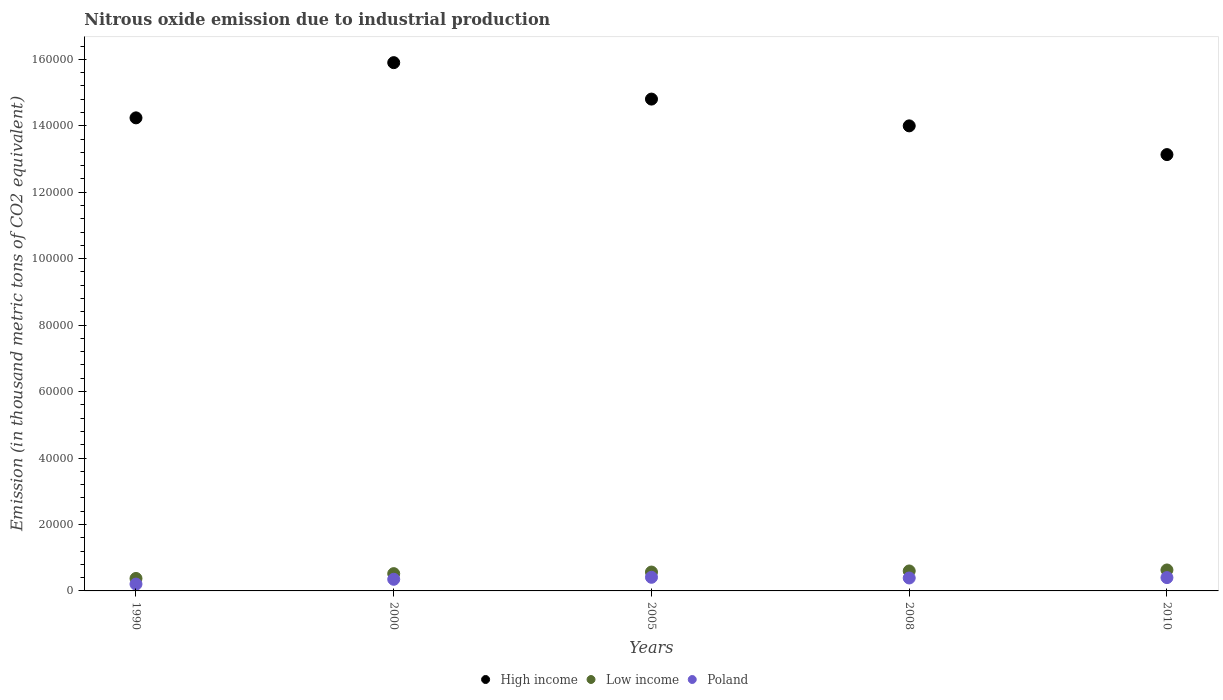How many different coloured dotlines are there?
Your answer should be compact. 3. Is the number of dotlines equal to the number of legend labels?
Your response must be concise. Yes. What is the amount of nitrous oxide emitted in High income in 2000?
Provide a succinct answer. 1.59e+05. Across all years, what is the maximum amount of nitrous oxide emitted in Low income?
Provide a short and direct response. 6305.5. Across all years, what is the minimum amount of nitrous oxide emitted in Poland?
Your answer should be very brief. 2055.6. In which year was the amount of nitrous oxide emitted in High income minimum?
Keep it short and to the point. 2010. What is the total amount of nitrous oxide emitted in High income in the graph?
Ensure brevity in your answer.  7.21e+05. What is the difference between the amount of nitrous oxide emitted in Poland in 2005 and that in 2010?
Your answer should be compact. 92.5. What is the difference between the amount of nitrous oxide emitted in Poland in 2010 and the amount of nitrous oxide emitted in High income in 2008?
Give a very brief answer. -1.36e+05. What is the average amount of nitrous oxide emitted in Low income per year?
Offer a terse response. 5389.32. In the year 2008, what is the difference between the amount of nitrous oxide emitted in Low income and amount of nitrous oxide emitted in High income?
Keep it short and to the point. -1.34e+05. In how many years, is the amount of nitrous oxide emitted in Low income greater than 120000 thousand metric tons?
Keep it short and to the point. 0. What is the ratio of the amount of nitrous oxide emitted in High income in 2008 to that in 2010?
Give a very brief answer. 1.07. Is the amount of nitrous oxide emitted in Low income in 1990 less than that in 2000?
Ensure brevity in your answer.  Yes. Is the difference between the amount of nitrous oxide emitted in Low income in 2000 and 2010 greater than the difference between the amount of nitrous oxide emitted in High income in 2000 and 2010?
Make the answer very short. No. What is the difference between the highest and the second highest amount of nitrous oxide emitted in Low income?
Give a very brief answer. 298. What is the difference between the highest and the lowest amount of nitrous oxide emitted in Low income?
Give a very brief answer. 2554.2. In how many years, is the amount of nitrous oxide emitted in Poland greater than the average amount of nitrous oxide emitted in Poland taken over all years?
Offer a terse response. 3. Is it the case that in every year, the sum of the amount of nitrous oxide emitted in High income and amount of nitrous oxide emitted in Low income  is greater than the amount of nitrous oxide emitted in Poland?
Offer a terse response. Yes. What is the difference between two consecutive major ticks on the Y-axis?
Ensure brevity in your answer.  2.00e+04. Are the values on the major ticks of Y-axis written in scientific E-notation?
Provide a succinct answer. No. Does the graph contain any zero values?
Your response must be concise. No. Where does the legend appear in the graph?
Offer a terse response. Bottom center. What is the title of the graph?
Provide a short and direct response. Nitrous oxide emission due to industrial production. Does "Belgium" appear as one of the legend labels in the graph?
Keep it short and to the point. No. What is the label or title of the Y-axis?
Give a very brief answer. Emission (in thousand metric tons of CO2 equivalent). What is the Emission (in thousand metric tons of CO2 equivalent) of High income in 1990?
Give a very brief answer. 1.42e+05. What is the Emission (in thousand metric tons of CO2 equivalent) in Low income in 1990?
Offer a very short reply. 3751.3. What is the Emission (in thousand metric tons of CO2 equivalent) of Poland in 1990?
Offer a very short reply. 2055.6. What is the Emission (in thousand metric tons of CO2 equivalent) of High income in 2000?
Give a very brief answer. 1.59e+05. What is the Emission (in thousand metric tons of CO2 equivalent) in Low income in 2000?
Make the answer very short. 5201.5. What is the Emission (in thousand metric tons of CO2 equivalent) of Poland in 2000?
Offer a very short reply. 3499.7. What is the Emission (in thousand metric tons of CO2 equivalent) in High income in 2005?
Ensure brevity in your answer.  1.48e+05. What is the Emission (in thousand metric tons of CO2 equivalent) of Low income in 2005?
Keep it short and to the point. 5680.8. What is the Emission (in thousand metric tons of CO2 equivalent) of Poland in 2005?
Offer a terse response. 4101.5. What is the Emission (in thousand metric tons of CO2 equivalent) in High income in 2008?
Your answer should be compact. 1.40e+05. What is the Emission (in thousand metric tons of CO2 equivalent) of Low income in 2008?
Your answer should be compact. 6007.5. What is the Emission (in thousand metric tons of CO2 equivalent) in Poland in 2008?
Provide a succinct answer. 3892.6. What is the Emission (in thousand metric tons of CO2 equivalent) of High income in 2010?
Provide a succinct answer. 1.31e+05. What is the Emission (in thousand metric tons of CO2 equivalent) in Low income in 2010?
Your answer should be very brief. 6305.5. What is the Emission (in thousand metric tons of CO2 equivalent) of Poland in 2010?
Make the answer very short. 4009. Across all years, what is the maximum Emission (in thousand metric tons of CO2 equivalent) in High income?
Your answer should be compact. 1.59e+05. Across all years, what is the maximum Emission (in thousand metric tons of CO2 equivalent) in Low income?
Your answer should be very brief. 6305.5. Across all years, what is the maximum Emission (in thousand metric tons of CO2 equivalent) in Poland?
Provide a short and direct response. 4101.5. Across all years, what is the minimum Emission (in thousand metric tons of CO2 equivalent) in High income?
Give a very brief answer. 1.31e+05. Across all years, what is the minimum Emission (in thousand metric tons of CO2 equivalent) in Low income?
Your response must be concise. 3751.3. Across all years, what is the minimum Emission (in thousand metric tons of CO2 equivalent) of Poland?
Offer a terse response. 2055.6. What is the total Emission (in thousand metric tons of CO2 equivalent) in High income in the graph?
Give a very brief answer. 7.21e+05. What is the total Emission (in thousand metric tons of CO2 equivalent) of Low income in the graph?
Provide a short and direct response. 2.69e+04. What is the total Emission (in thousand metric tons of CO2 equivalent) in Poland in the graph?
Ensure brevity in your answer.  1.76e+04. What is the difference between the Emission (in thousand metric tons of CO2 equivalent) in High income in 1990 and that in 2000?
Offer a terse response. -1.66e+04. What is the difference between the Emission (in thousand metric tons of CO2 equivalent) in Low income in 1990 and that in 2000?
Your response must be concise. -1450.2. What is the difference between the Emission (in thousand metric tons of CO2 equivalent) of Poland in 1990 and that in 2000?
Offer a terse response. -1444.1. What is the difference between the Emission (in thousand metric tons of CO2 equivalent) in High income in 1990 and that in 2005?
Keep it short and to the point. -5648.4. What is the difference between the Emission (in thousand metric tons of CO2 equivalent) of Low income in 1990 and that in 2005?
Make the answer very short. -1929.5. What is the difference between the Emission (in thousand metric tons of CO2 equivalent) in Poland in 1990 and that in 2005?
Your response must be concise. -2045.9. What is the difference between the Emission (in thousand metric tons of CO2 equivalent) of High income in 1990 and that in 2008?
Your answer should be very brief. 2410.2. What is the difference between the Emission (in thousand metric tons of CO2 equivalent) of Low income in 1990 and that in 2008?
Offer a terse response. -2256.2. What is the difference between the Emission (in thousand metric tons of CO2 equivalent) in Poland in 1990 and that in 2008?
Give a very brief answer. -1837. What is the difference between the Emission (in thousand metric tons of CO2 equivalent) of High income in 1990 and that in 2010?
Offer a terse response. 1.11e+04. What is the difference between the Emission (in thousand metric tons of CO2 equivalent) in Low income in 1990 and that in 2010?
Your answer should be very brief. -2554.2. What is the difference between the Emission (in thousand metric tons of CO2 equivalent) in Poland in 1990 and that in 2010?
Ensure brevity in your answer.  -1953.4. What is the difference between the Emission (in thousand metric tons of CO2 equivalent) in High income in 2000 and that in 2005?
Offer a terse response. 1.10e+04. What is the difference between the Emission (in thousand metric tons of CO2 equivalent) of Low income in 2000 and that in 2005?
Your response must be concise. -479.3. What is the difference between the Emission (in thousand metric tons of CO2 equivalent) in Poland in 2000 and that in 2005?
Your answer should be very brief. -601.8. What is the difference between the Emission (in thousand metric tons of CO2 equivalent) in High income in 2000 and that in 2008?
Your response must be concise. 1.90e+04. What is the difference between the Emission (in thousand metric tons of CO2 equivalent) in Low income in 2000 and that in 2008?
Offer a terse response. -806. What is the difference between the Emission (in thousand metric tons of CO2 equivalent) in Poland in 2000 and that in 2008?
Keep it short and to the point. -392.9. What is the difference between the Emission (in thousand metric tons of CO2 equivalent) of High income in 2000 and that in 2010?
Your answer should be very brief. 2.77e+04. What is the difference between the Emission (in thousand metric tons of CO2 equivalent) of Low income in 2000 and that in 2010?
Provide a succinct answer. -1104. What is the difference between the Emission (in thousand metric tons of CO2 equivalent) in Poland in 2000 and that in 2010?
Offer a very short reply. -509.3. What is the difference between the Emission (in thousand metric tons of CO2 equivalent) of High income in 2005 and that in 2008?
Offer a terse response. 8058.6. What is the difference between the Emission (in thousand metric tons of CO2 equivalent) of Low income in 2005 and that in 2008?
Offer a very short reply. -326.7. What is the difference between the Emission (in thousand metric tons of CO2 equivalent) of Poland in 2005 and that in 2008?
Provide a short and direct response. 208.9. What is the difference between the Emission (in thousand metric tons of CO2 equivalent) in High income in 2005 and that in 2010?
Provide a succinct answer. 1.67e+04. What is the difference between the Emission (in thousand metric tons of CO2 equivalent) in Low income in 2005 and that in 2010?
Provide a succinct answer. -624.7. What is the difference between the Emission (in thousand metric tons of CO2 equivalent) of Poland in 2005 and that in 2010?
Provide a short and direct response. 92.5. What is the difference between the Emission (in thousand metric tons of CO2 equivalent) in High income in 2008 and that in 2010?
Keep it short and to the point. 8647.3. What is the difference between the Emission (in thousand metric tons of CO2 equivalent) of Low income in 2008 and that in 2010?
Provide a succinct answer. -298. What is the difference between the Emission (in thousand metric tons of CO2 equivalent) in Poland in 2008 and that in 2010?
Provide a short and direct response. -116.4. What is the difference between the Emission (in thousand metric tons of CO2 equivalent) in High income in 1990 and the Emission (in thousand metric tons of CO2 equivalent) in Low income in 2000?
Offer a terse response. 1.37e+05. What is the difference between the Emission (in thousand metric tons of CO2 equivalent) of High income in 1990 and the Emission (in thousand metric tons of CO2 equivalent) of Poland in 2000?
Give a very brief answer. 1.39e+05. What is the difference between the Emission (in thousand metric tons of CO2 equivalent) in Low income in 1990 and the Emission (in thousand metric tons of CO2 equivalent) in Poland in 2000?
Ensure brevity in your answer.  251.6. What is the difference between the Emission (in thousand metric tons of CO2 equivalent) in High income in 1990 and the Emission (in thousand metric tons of CO2 equivalent) in Low income in 2005?
Keep it short and to the point. 1.37e+05. What is the difference between the Emission (in thousand metric tons of CO2 equivalent) in High income in 1990 and the Emission (in thousand metric tons of CO2 equivalent) in Poland in 2005?
Give a very brief answer. 1.38e+05. What is the difference between the Emission (in thousand metric tons of CO2 equivalent) of Low income in 1990 and the Emission (in thousand metric tons of CO2 equivalent) of Poland in 2005?
Your response must be concise. -350.2. What is the difference between the Emission (in thousand metric tons of CO2 equivalent) of High income in 1990 and the Emission (in thousand metric tons of CO2 equivalent) of Low income in 2008?
Provide a short and direct response. 1.36e+05. What is the difference between the Emission (in thousand metric tons of CO2 equivalent) of High income in 1990 and the Emission (in thousand metric tons of CO2 equivalent) of Poland in 2008?
Ensure brevity in your answer.  1.38e+05. What is the difference between the Emission (in thousand metric tons of CO2 equivalent) of Low income in 1990 and the Emission (in thousand metric tons of CO2 equivalent) of Poland in 2008?
Make the answer very short. -141.3. What is the difference between the Emission (in thousand metric tons of CO2 equivalent) in High income in 1990 and the Emission (in thousand metric tons of CO2 equivalent) in Low income in 2010?
Keep it short and to the point. 1.36e+05. What is the difference between the Emission (in thousand metric tons of CO2 equivalent) of High income in 1990 and the Emission (in thousand metric tons of CO2 equivalent) of Poland in 2010?
Keep it short and to the point. 1.38e+05. What is the difference between the Emission (in thousand metric tons of CO2 equivalent) in Low income in 1990 and the Emission (in thousand metric tons of CO2 equivalent) in Poland in 2010?
Provide a succinct answer. -257.7. What is the difference between the Emission (in thousand metric tons of CO2 equivalent) in High income in 2000 and the Emission (in thousand metric tons of CO2 equivalent) in Low income in 2005?
Your answer should be very brief. 1.53e+05. What is the difference between the Emission (in thousand metric tons of CO2 equivalent) of High income in 2000 and the Emission (in thousand metric tons of CO2 equivalent) of Poland in 2005?
Offer a very short reply. 1.55e+05. What is the difference between the Emission (in thousand metric tons of CO2 equivalent) of Low income in 2000 and the Emission (in thousand metric tons of CO2 equivalent) of Poland in 2005?
Keep it short and to the point. 1100. What is the difference between the Emission (in thousand metric tons of CO2 equivalent) in High income in 2000 and the Emission (in thousand metric tons of CO2 equivalent) in Low income in 2008?
Keep it short and to the point. 1.53e+05. What is the difference between the Emission (in thousand metric tons of CO2 equivalent) of High income in 2000 and the Emission (in thousand metric tons of CO2 equivalent) of Poland in 2008?
Make the answer very short. 1.55e+05. What is the difference between the Emission (in thousand metric tons of CO2 equivalent) in Low income in 2000 and the Emission (in thousand metric tons of CO2 equivalent) in Poland in 2008?
Your answer should be compact. 1308.9. What is the difference between the Emission (in thousand metric tons of CO2 equivalent) of High income in 2000 and the Emission (in thousand metric tons of CO2 equivalent) of Low income in 2010?
Offer a terse response. 1.53e+05. What is the difference between the Emission (in thousand metric tons of CO2 equivalent) of High income in 2000 and the Emission (in thousand metric tons of CO2 equivalent) of Poland in 2010?
Give a very brief answer. 1.55e+05. What is the difference between the Emission (in thousand metric tons of CO2 equivalent) of Low income in 2000 and the Emission (in thousand metric tons of CO2 equivalent) of Poland in 2010?
Ensure brevity in your answer.  1192.5. What is the difference between the Emission (in thousand metric tons of CO2 equivalent) of High income in 2005 and the Emission (in thousand metric tons of CO2 equivalent) of Low income in 2008?
Provide a succinct answer. 1.42e+05. What is the difference between the Emission (in thousand metric tons of CO2 equivalent) of High income in 2005 and the Emission (in thousand metric tons of CO2 equivalent) of Poland in 2008?
Your response must be concise. 1.44e+05. What is the difference between the Emission (in thousand metric tons of CO2 equivalent) of Low income in 2005 and the Emission (in thousand metric tons of CO2 equivalent) of Poland in 2008?
Provide a succinct answer. 1788.2. What is the difference between the Emission (in thousand metric tons of CO2 equivalent) of High income in 2005 and the Emission (in thousand metric tons of CO2 equivalent) of Low income in 2010?
Keep it short and to the point. 1.42e+05. What is the difference between the Emission (in thousand metric tons of CO2 equivalent) in High income in 2005 and the Emission (in thousand metric tons of CO2 equivalent) in Poland in 2010?
Give a very brief answer. 1.44e+05. What is the difference between the Emission (in thousand metric tons of CO2 equivalent) in Low income in 2005 and the Emission (in thousand metric tons of CO2 equivalent) in Poland in 2010?
Provide a succinct answer. 1671.8. What is the difference between the Emission (in thousand metric tons of CO2 equivalent) in High income in 2008 and the Emission (in thousand metric tons of CO2 equivalent) in Low income in 2010?
Your answer should be compact. 1.34e+05. What is the difference between the Emission (in thousand metric tons of CO2 equivalent) of High income in 2008 and the Emission (in thousand metric tons of CO2 equivalent) of Poland in 2010?
Your answer should be very brief. 1.36e+05. What is the difference between the Emission (in thousand metric tons of CO2 equivalent) in Low income in 2008 and the Emission (in thousand metric tons of CO2 equivalent) in Poland in 2010?
Offer a very short reply. 1998.5. What is the average Emission (in thousand metric tons of CO2 equivalent) of High income per year?
Provide a short and direct response. 1.44e+05. What is the average Emission (in thousand metric tons of CO2 equivalent) of Low income per year?
Your answer should be very brief. 5389.32. What is the average Emission (in thousand metric tons of CO2 equivalent) of Poland per year?
Make the answer very short. 3511.68. In the year 1990, what is the difference between the Emission (in thousand metric tons of CO2 equivalent) of High income and Emission (in thousand metric tons of CO2 equivalent) of Low income?
Provide a succinct answer. 1.39e+05. In the year 1990, what is the difference between the Emission (in thousand metric tons of CO2 equivalent) of High income and Emission (in thousand metric tons of CO2 equivalent) of Poland?
Offer a terse response. 1.40e+05. In the year 1990, what is the difference between the Emission (in thousand metric tons of CO2 equivalent) of Low income and Emission (in thousand metric tons of CO2 equivalent) of Poland?
Offer a very short reply. 1695.7. In the year 2000, what is the difference between the Emission (in thousand metric tons of CO2 equivalent) of High income and Emission (in thousand metric tons of CO2 equivalent) of Low income?
Offer a very short reply. 1.54e+05. In the year 2000, what is the difference between the Emission (in thousand metric tons of CO2 equivalent) in High income and Emission (in thousand metric tons of CO2 equivalent) in Poland?
Your answer should be compact. 1.56e+05. In the year 2000, what is the difference between the Emission (in thousand metric tons of CO2 equivalent) in Low income and Emission (in thousand metric tons of CO2 equivalent) in Poland?
Your response must be concise. 1701.8. In the year 2005, what is the difference between the Emission (in thousand metric tons of CO2 equivalent) of High income and Emission (in thousand metric tons of CO2 equivalent) of Low income?
Your answer should be compact. 1.42e+05. In the year 2005, what is the difference between the Emission (in thousand metric tons of CO2 equivalent) of High income and Emission (in thousand metric tons of CO2 equivalent) of Poland?
Provide a succinct answer. 1.44e+05. In the year 2005, what is the difference between the Emission (in thousand metric tons of CO2 equivalent) of Low income and Emission (in thousand metric tons of CO2 equivalent) of Poland?
Your answer should be very brief. 1579.3. In the year 2008, what is the difference between the Emission (in thousand metric tons of CO2 equivalent) in High income and Emission (in thousand metric tons of CO2 equivalent) in Low income?
Ensure brevity in your answer.  1.34e+05. In the year 2008, what is the difference between the Emission (in thousand metric tons of CO2 equivalent) of High income and Emission (in thousand metric tons of CO2 equivalent) of Poland?
Your answer should be very brief. 1.36e+05. In the year 2008, what is the difference between the Emission (in thousand metric tons of CO2 equivalent) in Low income and Emission (in thousand metric tons of CO2 equivalent) in Poland?
Offer a very short reply. 2114.9. In the year 2010, what is the difference between the Emission (in thousand metric tons of CO2 equivalent) of High income and Emission (in thousand metric tons of CO2 equivalent) of Low income?
Provide a succinct answer. 1.25e+05. In the year 2010, what is the difference between the Emission (in thousand metric tons of CO2 equivalent) of High income and Emission (in thousand metric tons of CO2 equivalent) of Poland?
Your response must be concise. 1.27e+05. In the year 2010, what is the difference between the Emission (in thousand metric tons of CO2 equivalent) in Low income and Emission (in thousand metric tons of CO2 equivalent) in Poland?
Your answer should be very brief. 2296.5. What is the ratio of the Emission (in thousand metric tons of CO2 equivalent) of High income in 1990 to that in 2000?
Offer a very short reply. 0.9. What is the ratio of the Emission (in thousand metric tons of CO2 equivalent) in Low income in 1990 to that in 2000?
Ensure brevity in your answer.  0.72. What is the ratio of the Emission (in thousand metric tons of CO2 equivalent) of Poland in 1990 to that in 2000?
Your response must be concise. 0.59. What is the ratio of the Emission (in thousand metric tons of CO2 equivalent) in High income in 1990 to that in 2005?
Your response must be concise. 0.96. What is the ratio of the Emission (in thousand metric tons of CO2 equivalent) of Low income in 1990 to that in 2005?
Offer a very short reply. 0.66. What is the ratio of the Emission (in thousand metric tons of CO2 equivalent) of Poland in 1990 to that in 2005?
Make the answer very short. 0.5. What is the ratio of the Emission (in thousand metric tons of CO2 equivalent) of High income in 1990 to that in 2008?
Make the answer very short. 1.02. What is the ratio of the Emission (in thousand metric tons of CO2 equivalent) in Low income in 1990 to that in 2008?
Offer a terse response. 0.62. What is the ratio of the Emission (in thousand metric tons of CO2 equivalent) in Poland in 1990 to that in 2008?
Offer a terse response. 0.53. What is the ratio of the Emission (in thousand metric tons of CO2 equivalent) of High income in 1990 to that in 2010?
Offer a very short reply. 1.08. What is the ratio of the Emission (in thousand metric tons of CO2 equivalent) in Low income in 1990 to that in 2010?
Provide a succinct answer. 0.59. What is the ratio of the Emission (in thousand metric tons of CO2 equivalent) of Poland in 1990 to that in 2010?
Your answer should be compact. 0.51. What is the ratio of the Emission (in thousand metric tons of CO2 equivalent) of High income in 2000 to that in 2005?
Offer a terse response. 1.07. What is the ratio of the Emission (in thousand metric tons of CO2 equivalent) of Low income in 2000 to that in 2005?
Keep it short and to the point. 0.92. What is the ratio of the Emission (in thousand metric tons of CO2 equivalent) in Poland in 2000 to that in 2005?
Provide a succinct answer. 0.85. What is the ratio of the Emission (in thousand metric tons of CO2 equivalent) in High income in 2000 to that in 2008?
Give a very brief answer. 1.14. What is the ratio of the Emission (in thousand metric tons of CO2 equivalent) of Low income in 2000 to that in 2008?
Offer a very short reply. 0.87. What is the ratio of the Emission (in thousand metric tons of CO2 equivalent) in Poland in 2000 to that in 2008?
Give a very brief answer. 0.9. What is the ratio of the Emission (in thousand metric tons of CO2 equivalent) in High income in 2000 to that in 2010?
Ensure brevity in your answer.  1.21. What is the ratio of the Emission (in thousand metric tons of CO2 equivalent) of Low income in 2000 to that in 2010?
Provide a succinct answer. 0.82. What is the ratio of the Emission (in thousand metric tons of CO2 equivalent) of Poland in 2000 to that in 2010?
Your answer should be compact. 0.87. What is the ratio of the Emission (in thousand metric tons of CO2 equivalent) in High income in 2005 to that in 2008?
Provide a succinct answer. 1.06. What is the ratio of the Emission (in thousand metric tons of CO2 equivalent) in Low income in 2005 to that in 2008?
Give a very brief answer. 0.95. What is the ratio of the Emission (in thousand metric tons of CO2 equivalent) in Poland in 2005 to that in 2008?
Make the answer very short. 1.05. What is the ratio of the Emission (in thousand metric tons of CO2 equivalent) of High income in 2005 to that in 2010?
Offer a terse response. 1.13. What is the ratio of the Emission (in thousand metric tons of CO2 equivalent) in Low income in 2005 to that in 2010?
Ensure brevity in your answer.  0.9. What is the ratio of the Emission (in thousand metric tons of CO2 equivalent) of Poland in 2005 to that in 2010?
Offer a very short reply. 1.02. What is the ratio of the Emission (in thousand metric tons of CO2 equivalent) in High income in 2008 to that in 2010?
Your response must be concise. 1.07. What is the ratio of the Emission (in thousand metric tons of CO2 equivalent) of Low income in 2008 to that in 2010?
Your answer should be compact. 0.95. What is the difference between the highest and the second highest Emission (in thousand metric tons of CO2 equivalent) of High income?
Offer a terse response. 1.10e+04. What is the difference between the highest and the second highest Emission (in thousand metric tons of CO2 equivalent) of Low income?
Provide a succinct answer. 298. What is the difference between the highest and the second highest Emission (in thousand metric tons of CO2 equivalent) in Poland?
Keep it short and to the point. 92.5. What is the difference between the highest and the lowest Emission (in thousand metric tons of CO2 equivalent) in High income?
Your answer should be compact. 2.77e+04. What is the difference between the highest and the lowest Emission (in thousand metric tons of CO2 equivalent) of Low income?
Keep it short and to the point. 2554.2. What is the difference between the highest and the lowest Emission (in thousand metric tons of CO2 equivalent) of Poland?
Provide a short and direct response. 2045.9. 